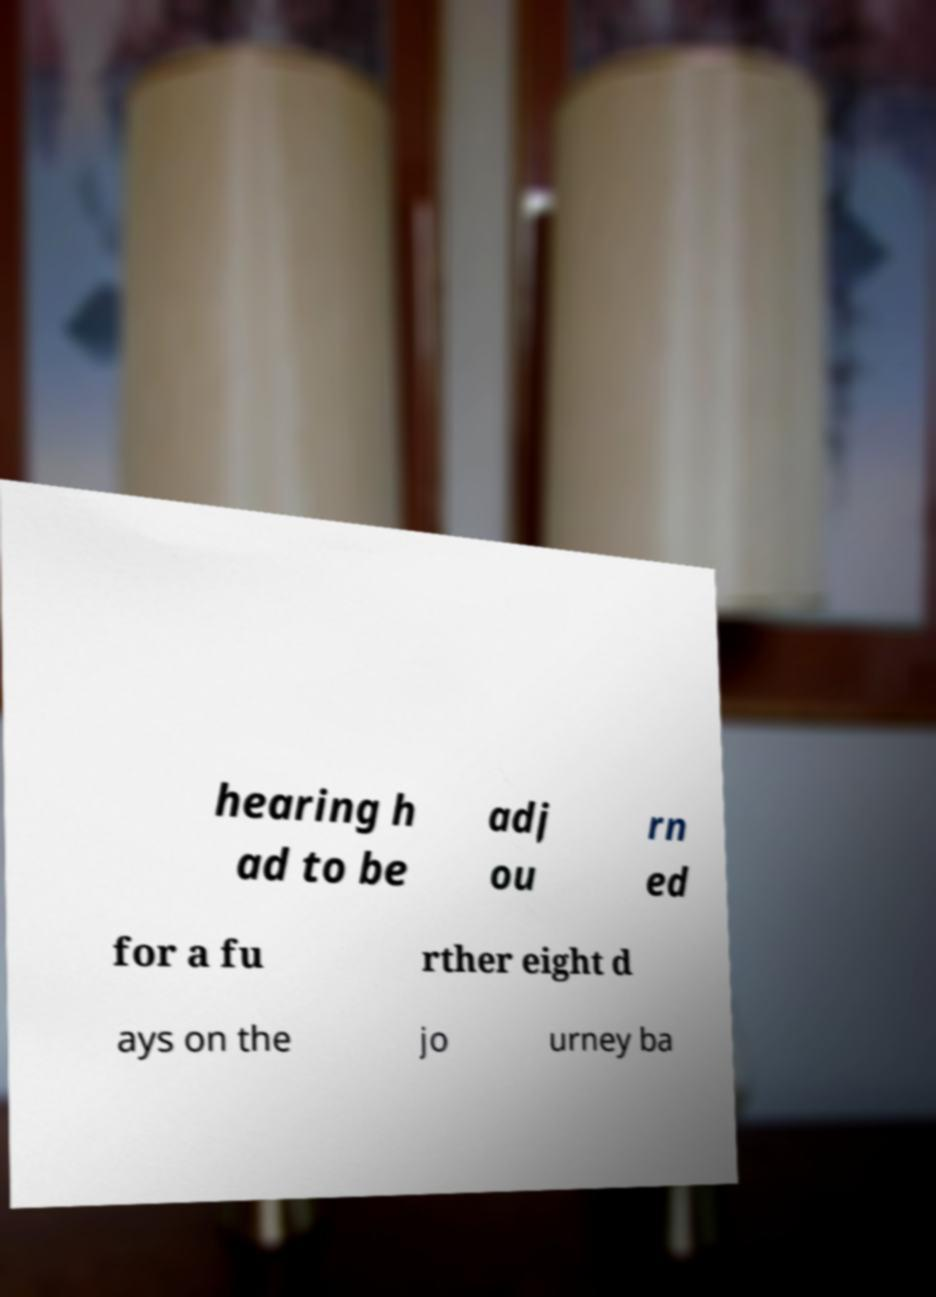There's text embedded in this image that I need extracted. Can you transcribe it verbatim? hearing h ad to be adj ou rn ed for a fu rther eight d ays on the jo urney ba 